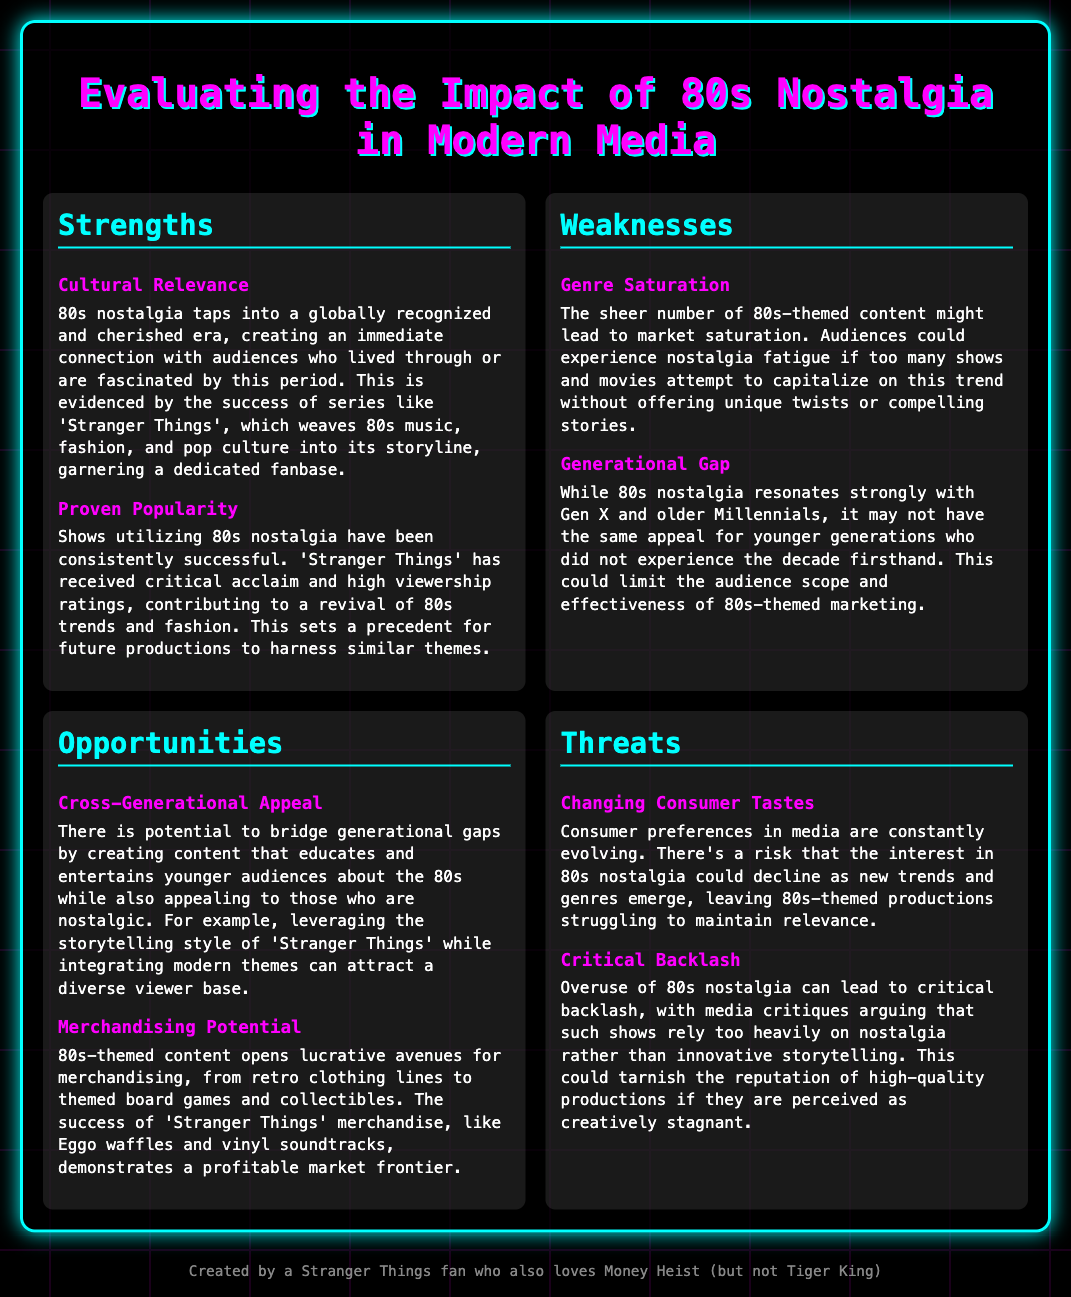What are two strengths of 80s nostalgia in modern media? The strengths listed are Cultural Relevance and Proven Popularity, which highlight the significance of the 80s era in captivating audiences.
Answer: Cultural Relevance, Proven Popularity What is the main weakness related to audience appeal? The document identifies the Generational Gap as a weakness, which indicates varying levels of resonance with different age groups.
Answer: Generational Gap What opportunity involves engaging younger audiences? The opportunity is Cross-Generational Appeal, which focuses on bridging gaps by educating younger viewers about the 80s.
Answer: Cross-Generational Appeal What threat pertains to consumer preferences? The document mentions Changing Consumer Tastes as a threat, indicating that evolving preferences could diminish interest in 80s nostalgia.
Answer: Changing Consumer Tastes How many strengths are identified in the SWOT analysis? According to the document, there are two strengths highlighted related to the impact of 80s nostalgia.
Answer: 2 Which popular Netflix series exemplifies the success of 80s-themed content? The analysis refers to 'Stranger Things' as a successful example of a show that incorporates 80s nostalgia.
Answer: Stranger Things What is one aspect of merchandising potential mentioned in the analysis? The detail indicates that merchandising can encompass retro clothing lines and themed collectibles resulting from 80s-themed content.
Answer: Retro clothing lines What could lead to critical backlash against 80s-themed media? The document cites Overuse of nostalgia as a potential cause for criticism, suggesting a reliance on past trends over new storytelling.
Answer: Overuse of nostalgia Which demographic is primarily nostalgic for the 80s era? The document notes that Gen X and older Millennials are the generations most affected by 80s nostalgia.
Answer: Gen X and older Millennials 